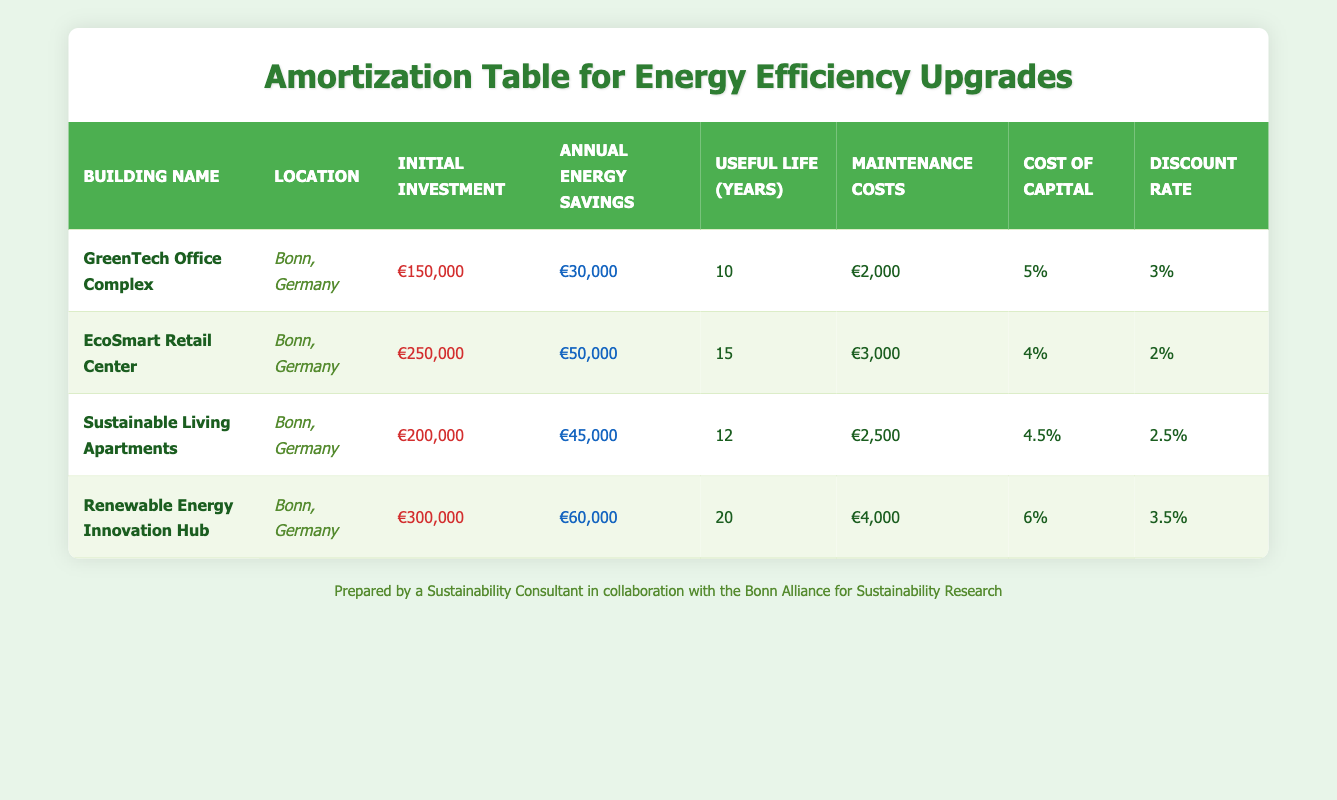What is the initial investment for the Sustainable Living Apartments? Referring to the table, we can see that the initial investment listed for the Sustainable Living Apartments is €200,000.
Answer: €200,000 Which building has the highest annual energy savings? The table shows that the Renewable Energy Innovation Hub has the highest annual energy savings of €60,000 compared to the other buildings listed.
Answer: Renewable Energy Innovation Hub What is the total annual maintenance cost for all buildings? The annual maintenance costs for each building are €2,000 (GreenTech), €3,000 (EcoSmart), €2,500 (Sustainable Living), and €4,000 (Renewable Energy Innovation Hub). Adding these gives us 2000 + 3000 + 2500 + 4000 = €11,500.
Answer: €11,500 Is the cost of capital for the EcoSmart Retail Center greater than that for the GreenTech Office Complex? The cost of capital for EcoSmart is 4% and for GreenTech is 5%. Since 4% is less than 5%, the statement is false.
Answer: No Calculating the average useful life of all listed buildings, what do we get? The useful lives of the buildings are 10, 15, 12, and 20 years. To find the average, we sum these values (10 + 15 + 12 + 20 = 57) and divide by the number of buildings (4). This gives us an average useful life of 57 / 4 = 14.25 years.
Answer: 14.25 years Which building has the lowest annual energy savings compared to the others? In the table, the GreenTech Office Complex shows the lowest annual energy savings of €30,000 when compared to the other buildings listed.
Answer: GreenTech Office Complex Is it true that all buildings have a useful life of more than 10 years? The useful life values are 10, 15, 12, and 20 years. Since the GreenTech Office Complex has a useful life of exactly 10 years, not all buildings exceed 10 years.
Answer: No What is the total initial investment for all buildings combined? Adding the initial investments: €150,000 (GreenTech) + €250,000 (EcoSmart) + €200,000 (Sustainable Living) + €300,000 (Renewable Energy) gives us a total of €150,000 + €250,000 + €200,000 + €300,000 = €900,000.
Answer: €900,000 